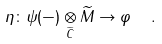Convert formula to latex. <formula><loc_0><loc_0><loc_500><loc_500>\eta \colon \psi ( - ) \underset { \widetilde { C } } { \otimes } \widetilde { M } \to \varphi \ \ .</formula> 